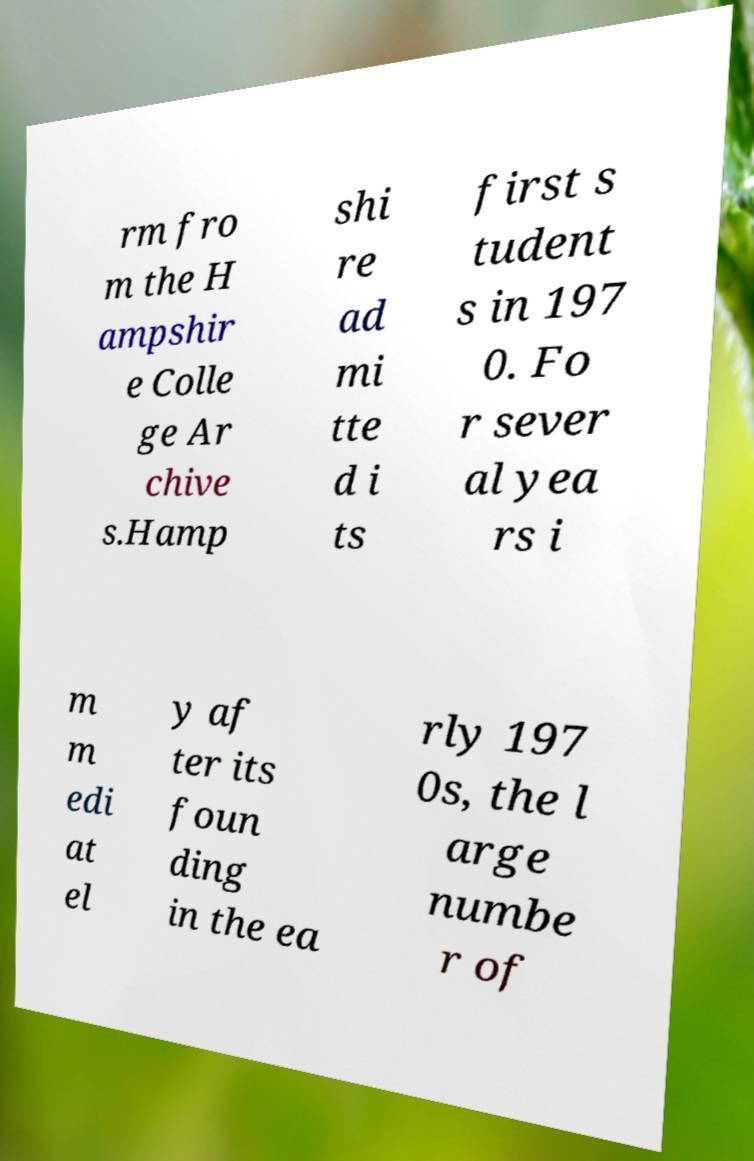Can you accurately transcribe the text from the provided image for me? rm fro m the H ampshir e Colle ge Ar chive s.Hamp shi re ad mi tte d i ts first s tudent s in 197 0. Fo r sever al yea rs i m m edi at el y af ter its foun ding in the ea rly 197 0s, the l arge numbe r of 